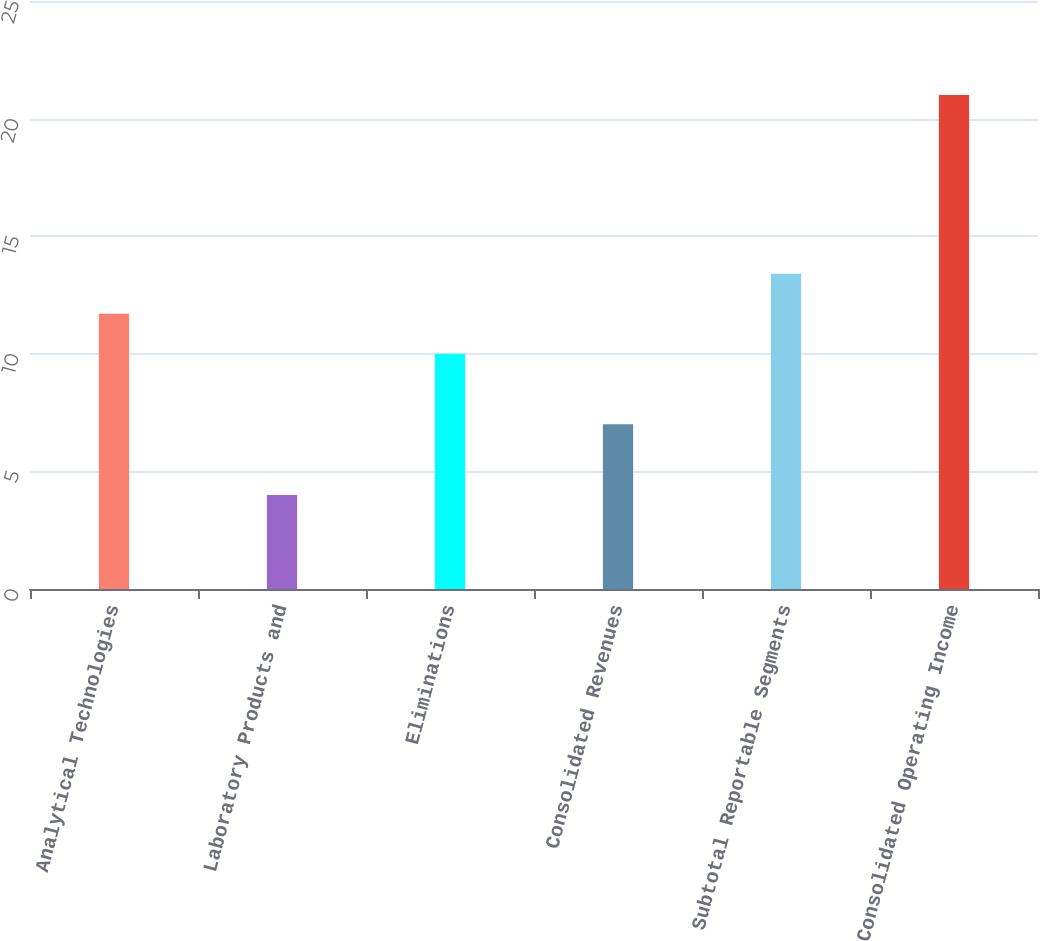Convert chart. <chart><loc_0><loc_0><loc_500><loc_500><bar_chart><fcel>Analytical Technologies<fcel>Laboratory Products and<fcel>Eliminations<fcel>Consolidated Revenues<fcel>Subtotal Reportable Segments<fcel>Consolidated Operating Income<nl><fcel>11.7<fcel>4<fcel>10<fcel>7<fcel>13.4<fcel>21<nl></chart> 